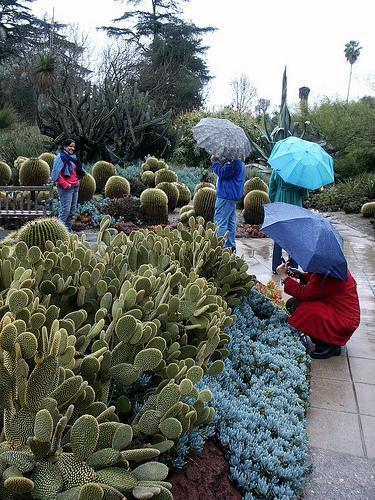How many umbrellas are in the photo?
Give a very brief answer. 3. How many people have red coats on?
Give a very brief answer. 1. How many people are in the photo?
Give a very brief answer. 4. 